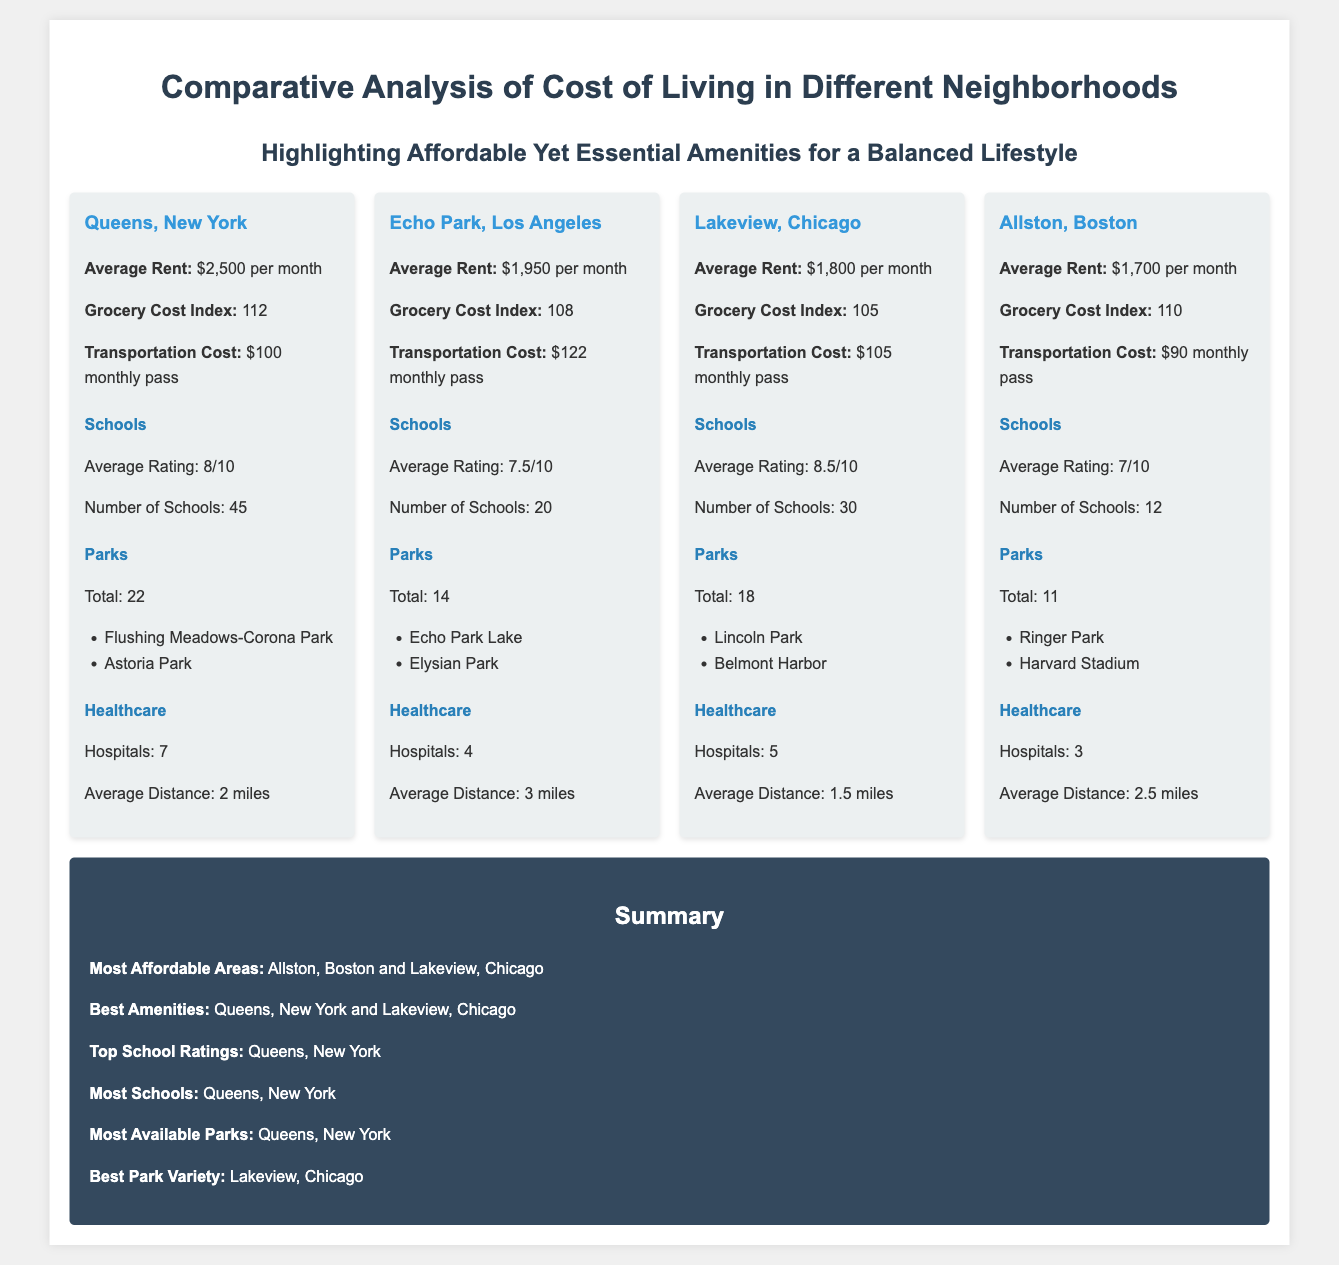What is the average rent in Queens, New York? The average rent in Queens is explicitly mentioned in the document as $2,500 per month.
Answer: $2,500 per month How many hospitals are there in Lakeview, Chicago? The document states that Lakeview has 5 hospitals listed under its amenities.
Answer: 5 Which neighborhood has the best park variety? The summary specifically notes that Lakeview, Chicago offers the best park variety compared to others listed.
Answer: Lakeview, Chicago What is the transportation cost for Allston, Boston? The document clearly states the transportation cost for Allston is $90 for a monthly pass.
Answer: $90 Which area has the highest average school rating? The summary indicates that Queens has the highest average school rating at 8/10.
Answer: Queens, New York How many parks are available in Echo Park, Los Angeles? The document specifies that Echo Park has a total of 14 parks.
Answer: 14 What is the grocery cost index for Allston, Boston? The document lists the grocery cost index for Allston as 110.
Answer: 110 Which neighborhood has the most schools? According to the summary, Queens has the most schools with a total of 45 listed.
Answer: Queens, New York 